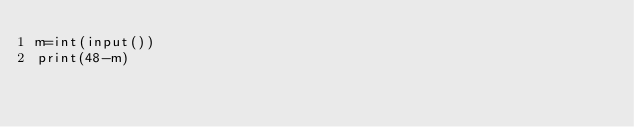Convert code to text. <code><loc_0><loc_0><loc_500><loc_500><_Python_>m=int(input())
print(48-m)</code> 